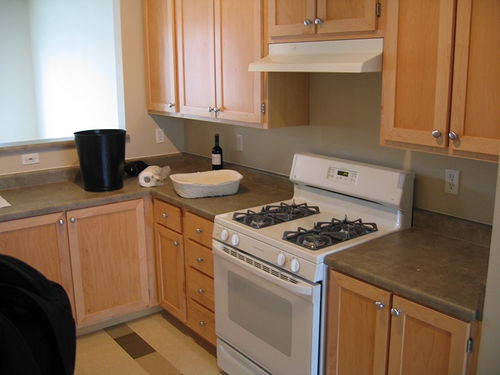Describe the objects in this image and their specific colors. I can see oven in darkgray and gray tones, bowl in darkgray, tan, and gray tones, bottle in darkgray, black, and gray tones, and sink in darkgray, tan, and gray tones in this image. 